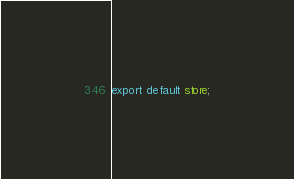Convert code to text. <code><loc_0><loc_0><loc_500><loc_500><_JavaScript_>
export default store;
</code> 